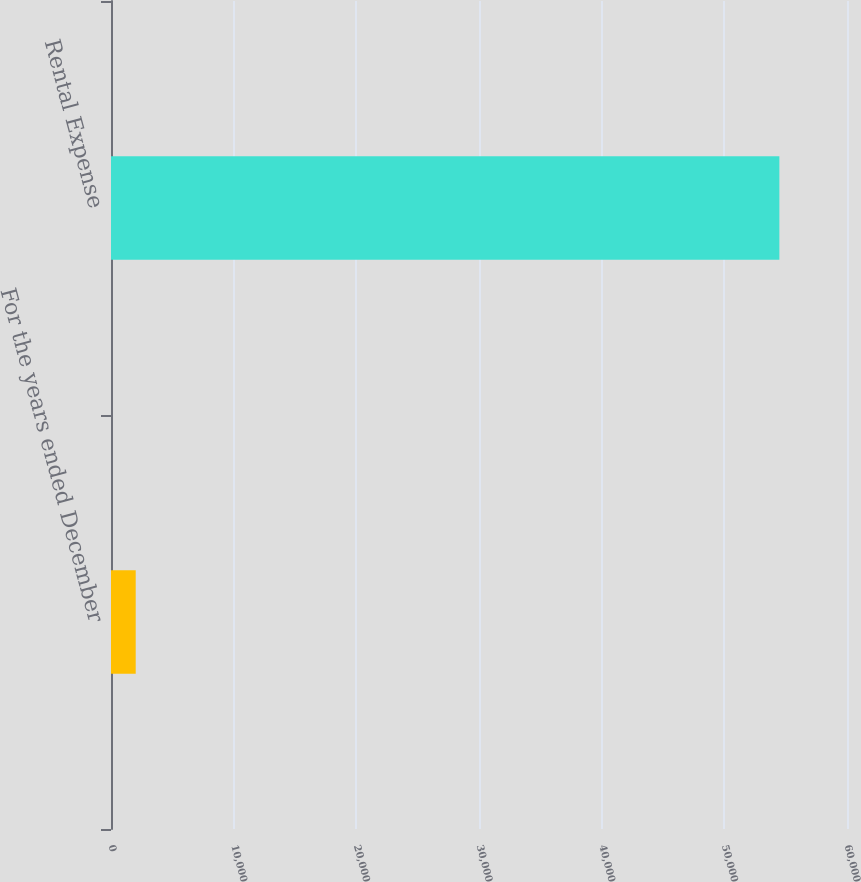Convert chart to OTSL. <chart><loc_0><loc_0><loc_500><loc_500><bar_chart><fcel>For the years ended December<fcel>Rental Expense<nl><fcel>2014<fcel>54487<nl></chart> 